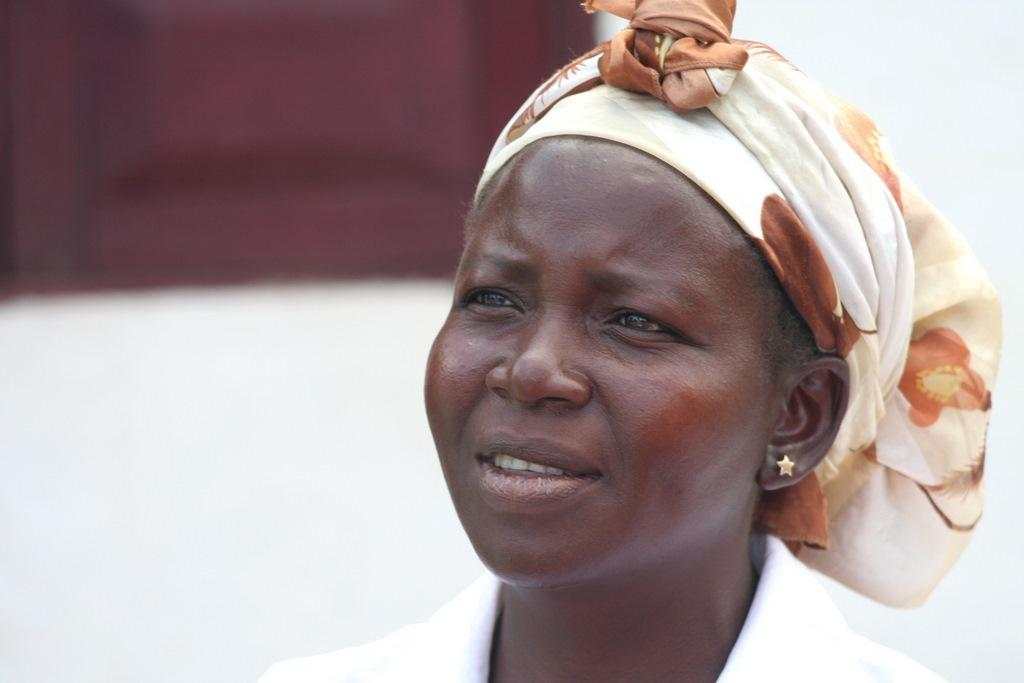Who is the main subject in the image? There is a woman in the picture. What is the woman wearing on her head? The woman is wearing a cloth on her head. What can be seen in the background of the image? There appears to be a window on the wall in the background of the image. What is the price of the chalk on the table in the image? There is no chalk or table present in the image. What type of hammer is the woman holding in the image? There is no hammer visible in the image. 